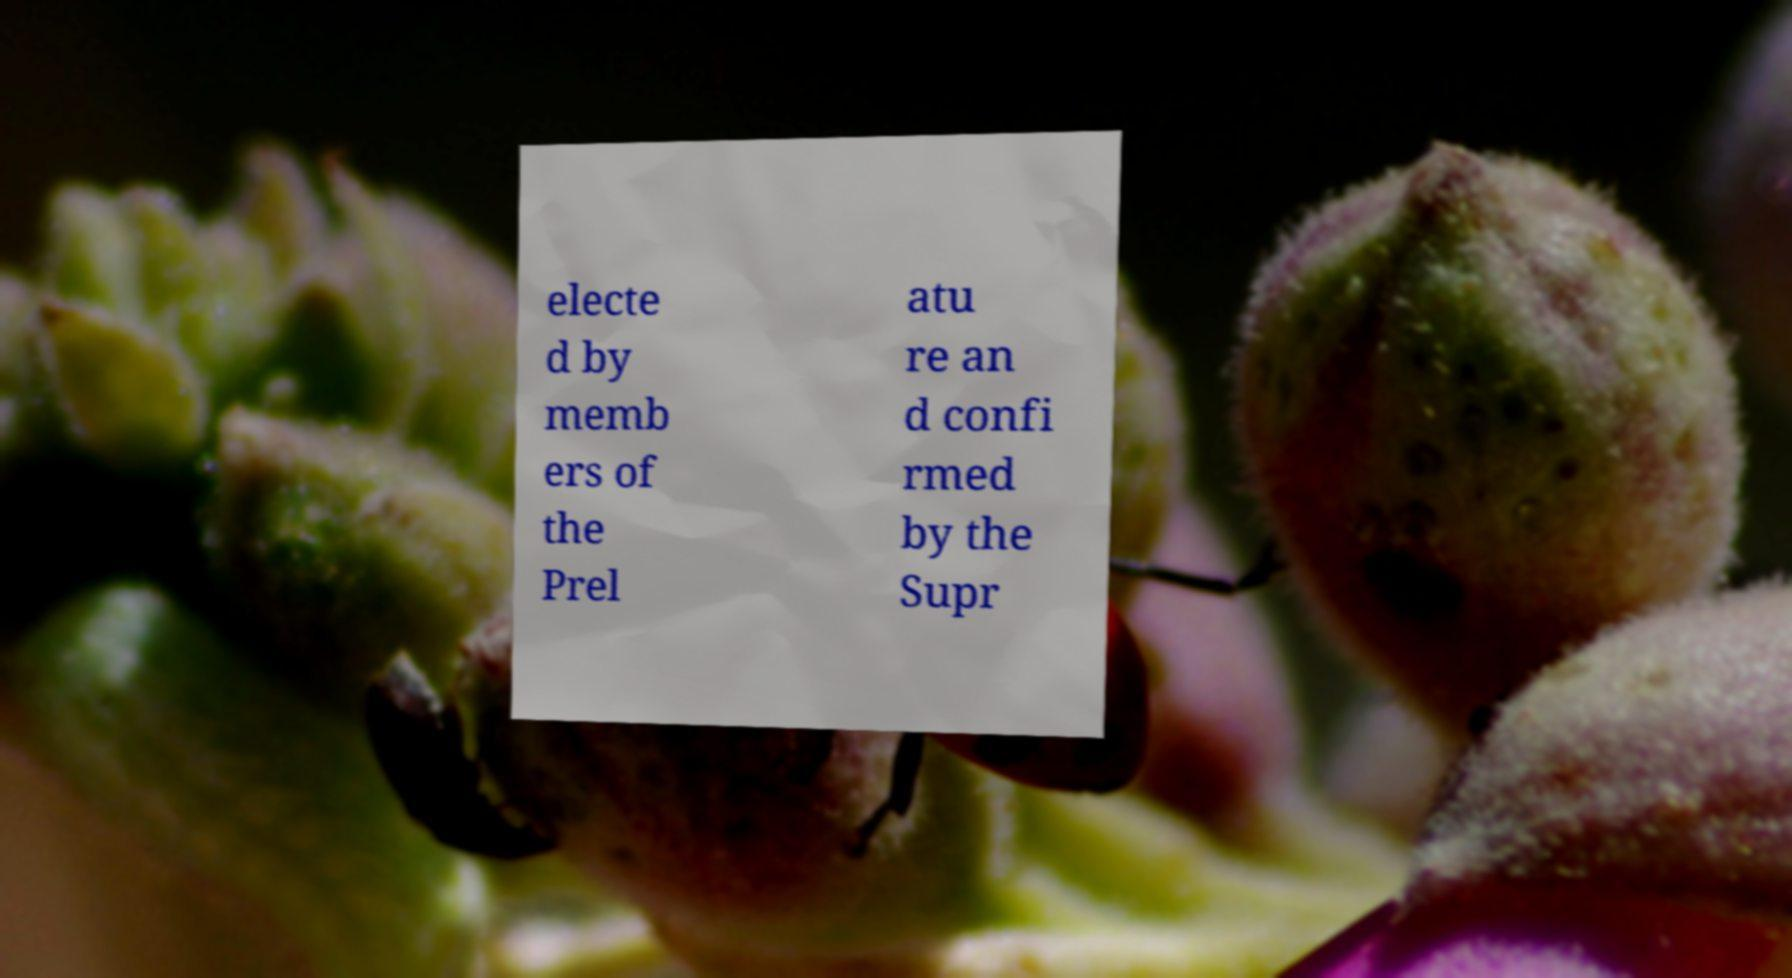There's text embedded in this image that I need extracted. Can you transcribe it verbatim? electe d by memb ers of the Prel atu re an d confi rmed by the Supr 